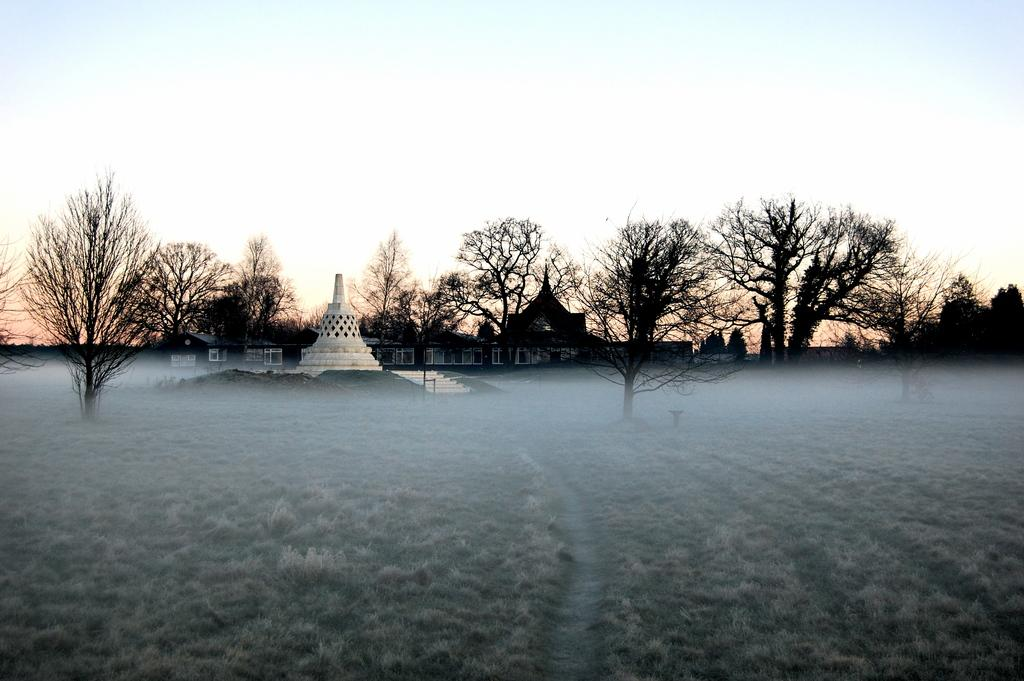What type of natural elements can be seen in the image? There are trees in the image. What type of man-made structures are present in the image? The image contains ancient architecture. What is visible at the base of the image? The ground is visible in the image. What part of the natural environment is visible in the background of the image? The sky is visible in the background of the image. What type of stamp can be seen on the ancient architecture in the image? There is no stamp present on the ancient architecture in the image. Who is the governor of the area depicted in the image? The image does not provide information about the governance of the area, so it is not possible to determine the governor. 